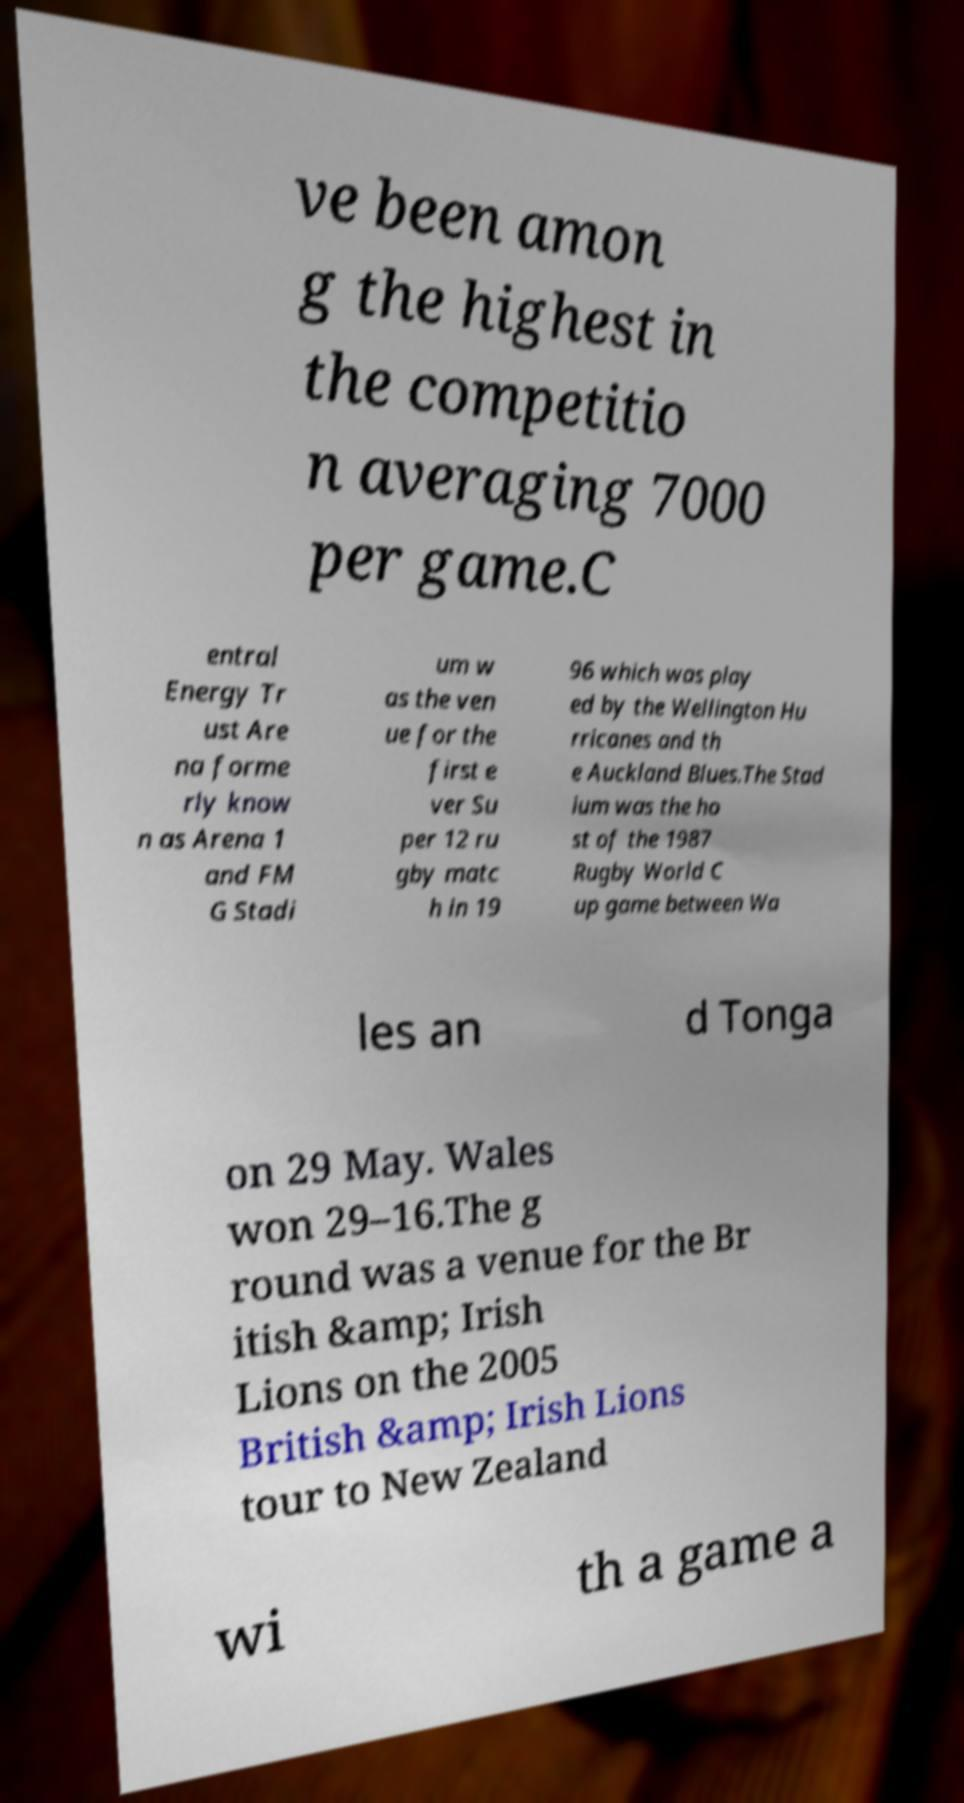Please identify and transcribe the text found in this image. ve been amon g the highest in the competitio n averaging 7000 per game.C entral Energy Tr ust Are na forme rly know n as Arena 1 and FM G Stadi um w as the ven ue for the first e ver Su per 12 ru gby matc h in 19 96 which was play ed by the Wellington Hu rricanes and th e Auckland Blues.The Stad ium was the ho st of the 1987 Rugby World C up game between Wa les an d Tonga on 29 May. Wales won 29–16.The g round was a venue for the Br itish &amp; Irish Lions on the 2005 British &amp; Irish Lions tour to New Zealand wi th a game a 